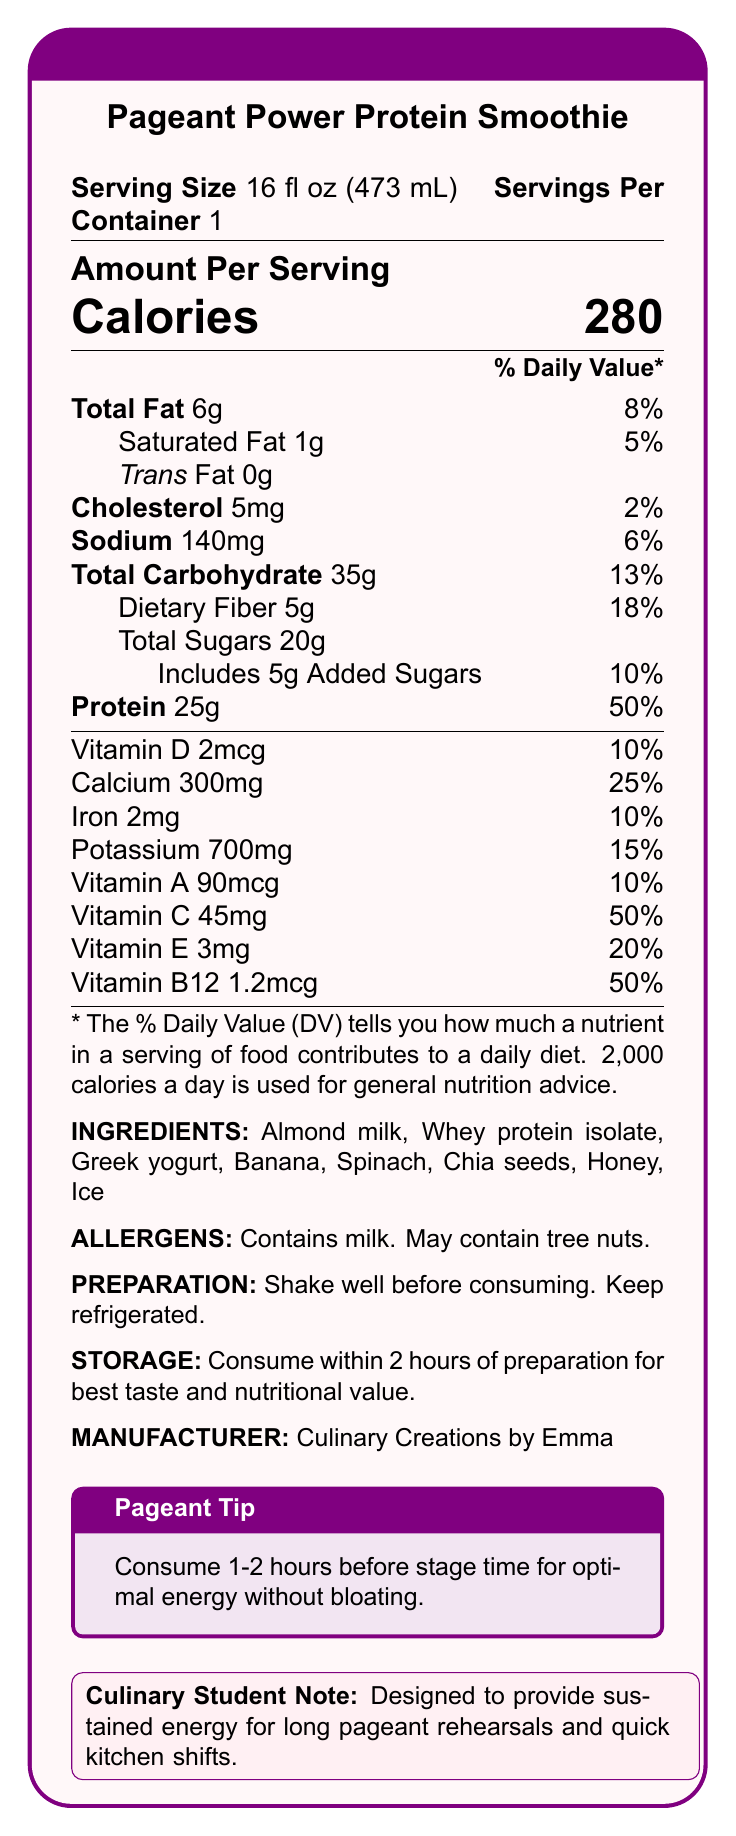what is the serving size for the Pageant Power Protein Smoothie? The serving size information is located at the top of the document under the product name.
Answer: 16 fl oz (473 mL) how many grams of protein does one serving contain? The amount of protein per serving is stated under the nutritional facts.
Answer: 25g what is the percent daily value of dietary fiber? The percent daily value is listed next to the amount of dietary fiber in the nutritional facts section.
Answer: 18% list three ingredients found in the Pageant Power Protein Smoothie. The ingredients are listed towards the end of the document.
Answer: Almond milk, Whey protein isolate, Greek yogurt what are the allergens in this smoothie? The allergen information is provided below the list of ingredients.
Answer: Contains milk, May contain tree nuts what is the total carbohydrate count per serving? The total carbohydrate content is listed in the nutritional facts section.
Answer: 35g how many calories are in one serving? A. 200 B. 280 C. 300 The calorie content per serving is listed prominently in the nutritional facts.
Answer: B. 280 what vitamins have a percent daily value of 50%? A. Vitamin C and Vitamin B12 B. Vitamin D and Vitamin A C. Vitamin E and Vitamin B12 The percent daily values for vitamins C and B12 are both listed as 50% in the nutritional facts.
Answer: A. Vitamin C and Vitamin B12 is the smoothie designed to provide energy for long pageant rehearsals? The culinary student note explicitly states that the smoothie is designed to provide sustained energy for long pageant rehearsals and quick kitchen shifts.
Answer: Yes describe the main focus of the Pageant Power Protein Smoothie nutrition facts document. The document focuses on delivering comprehensive nutrition facts, emphasizing its use for energy optimization during pageants and culinary activities.
Answer: The document provides detailed nutritional information, ingredients, allergen warnings, preparation, and storage instructions for the Pageant Power Protein Smoothie. It highlights the smoothie’s high protein content and suitability for pre-pageant energy boosts, with additional notes and tips for culinary students. how should the smoothie be stored for best taste and nutritional value? The storage instructions specify consuming within 2 hours of preparation for optimal quality.
Answer: Consume within 2 hours of preparation for best taste and nutritional value. does the smoothie contain any trans fat? The document lists trans fat content as 0g in the nutritional facts section.
Answer: No what is the amount of potassium in each serving of the smoothie? The potassium content is provided in the nutritional facts section.
Answer: 700mg who manufactures the Pageant Power Protein Smoothie? The manufacturer information is listed at the end of the document.
Answer: Culinary Creations by Emma how many servings are in one container of the smoothie? This information can be found under the serving size at the top of the document.
Answer: 1 what specific preparation instruction is mentioned for the smoothie? The preparation instructions indicate shaking well and keeping the smoothie refrigerated.
Answer: Shake well before consuming. Keep refrigerated. what is the percent daily value of added sugars in the smoothie? The percent daily value for added sugars is mentioned along with the amount of added sugars in the nutritional facts.
Answer: 10% is there any information on the cost of the smoothie? The document does not provide any details related to the cost or pricing of the smoothie.
Answer: Cannot be determined 